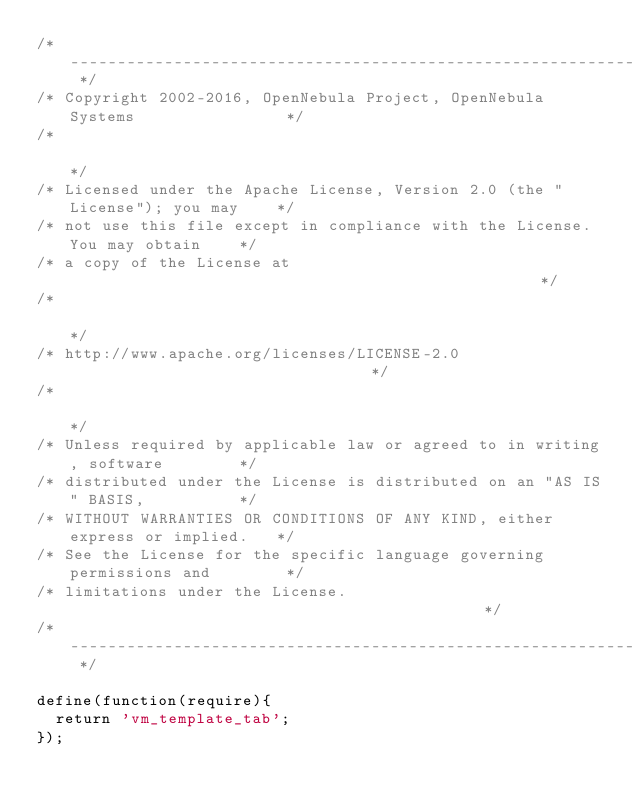Convert code to text. <code><loc_0><loc_0><loc_500><loc_500><_JavaScript_>/* -------------------------------------------------------------------------- */
/* Copyright 2002-2016, OpenNebula Project, OpenNebula Systems                */
/*                                                                            */
/* Licensed under the Apache License, Version 2.0 (the "License"); you may    */
/* not use this file except in compliance with the License. You may obtain    */
/* a copy of the License at                                                   */
/*                                                                            */
/* http://www.apache.org/licenses/LICENSE-2.0                                 */
/*                                                                            */
/* Unless required by applicable law or agreed to in writing, software        */
/* distributed under the License is distributed on an "AS IS" BASIS,          */
/* WITHOUT WARRANTIES OR CONDITIONS OF ANY KIND, either express or implied.   */
/* See the License for the specific language governing permissions and        */
/* limitations under the License.                                             */
/* -------------------------------------------------------------------------- */

define(function(require){
  return 'vm_template_tab';
});
</code> 